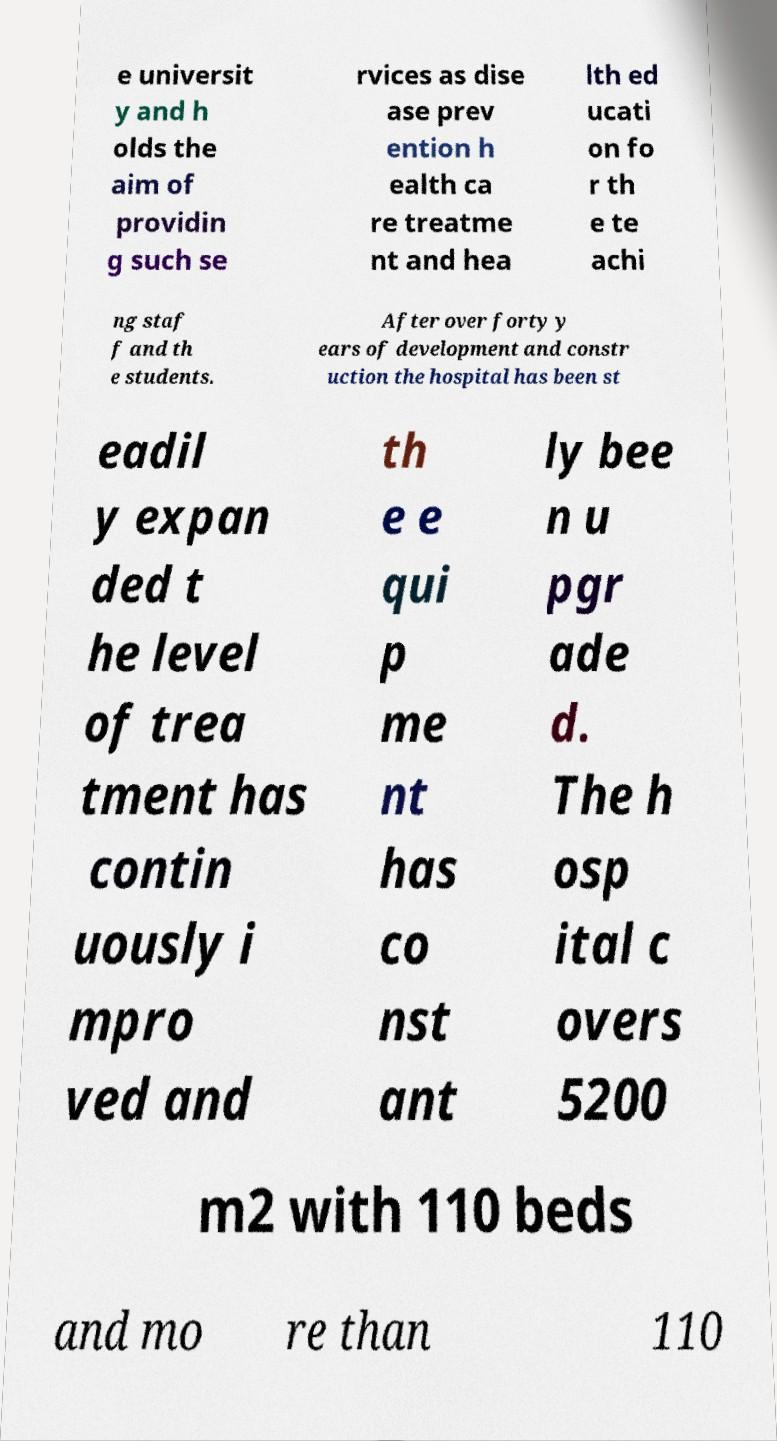What messages or text are displayed in this image? I need them in a readable, typed format. e universit y and h olds the aim of providin g such se rvices as dise ase prev ention h ealth ca re treatme nt and hea lth ed ucati on fo r th e te achi ng staf f and th e students. After over forty y ears of development and constr uction the hospital has been st eadil y expan ded t he level of trea tment has contin uously i mpro ved and th e e qui p me nt has co nst ant ly bee n u pgr ade d. The h osp ital c overs 5200 m2 with 110 beds and mo re than 110 